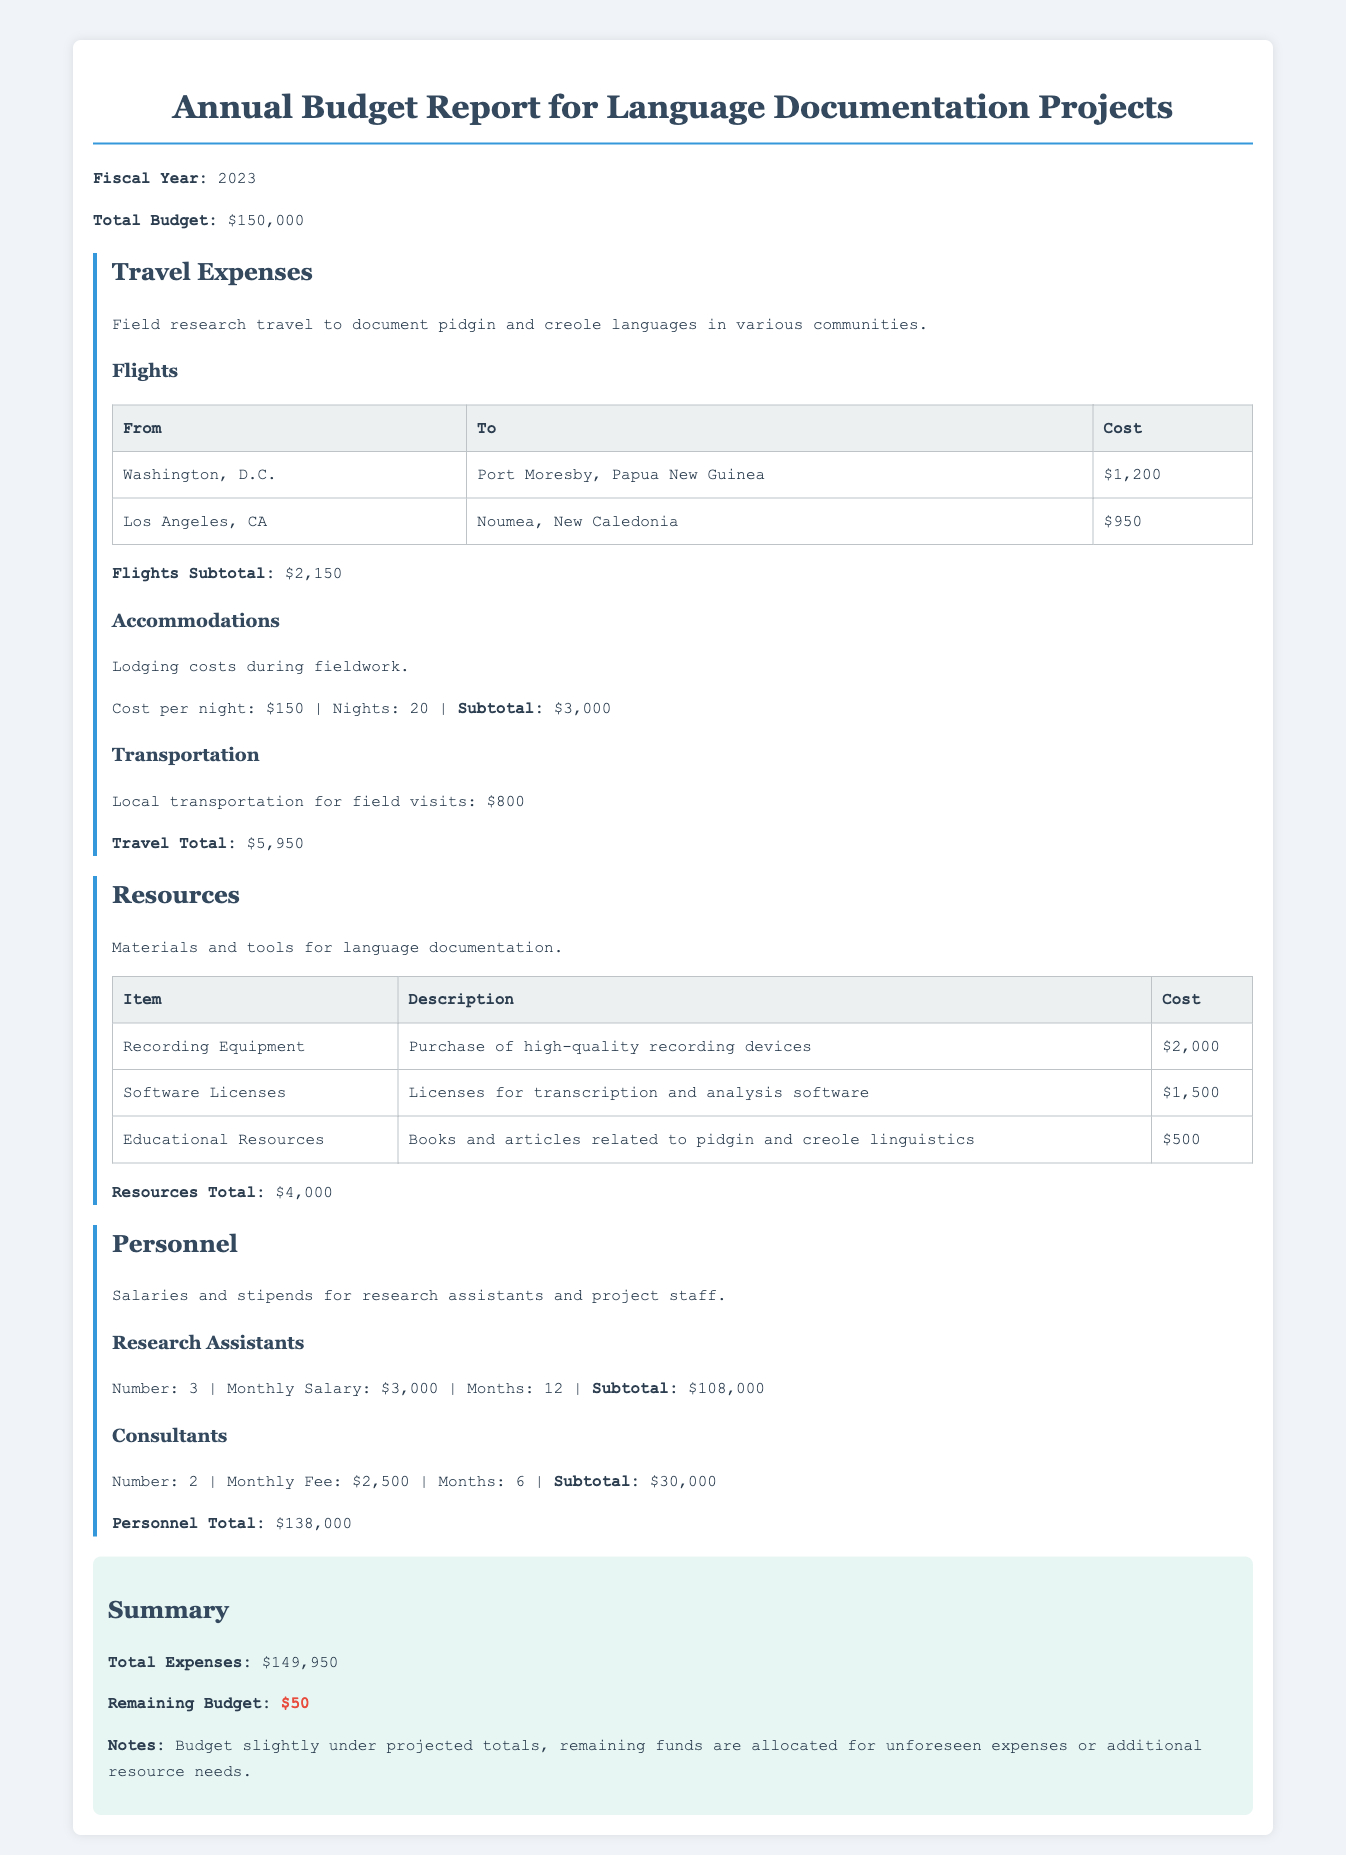What is the total budget for the fiscal year? The total budget is outlined in the document and is stated at the very beginning.
Answer: $150,000 How much is allocated for flights in travel expenses? The document lists the costs for flights under travel expenses, which adds up to $2,150.
Answer: $2,150 What is the subtotal for accommodation costs? Accommodation costs are detailed under travel expenses, where it shows the cost per night multiplied by the number of nights.
Answer: $3,000 How many research assistants are included in the personnel section? The personnel section specifies the number of research assistants working on the project, which is clearly mentioned.
Answer: 3 What is the total amount spent on resources? The resources section of the document provides a detailed breakdown that culminates in a total expense figure.
Answer: $4,000 What percentage of the total budget is spent on personnel? To find this involves calculating the ratio of personnel expenses to the total budget, which is lined out in the respective section.
Answer: 92% What remaining budget is noted at the end of the report? The report summarizes the total expenses and any residual funds at the end, which is highlighted for easy visibility.
Answer: $50 How much is allocated for local transportation in travel expenses? The document mentions this specific cost in the travel section, indicating its relevance and importance.
Answer: $800 What are the months accounted for in the consultants' fees? The consultants' fees breakdown specifies the duration for which they are engaged, providing clarity on the contract terms.
Answer: 6 